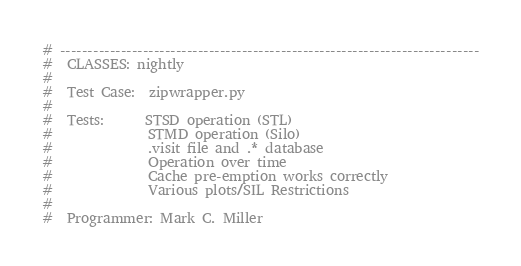Convert code to text. <code><loc_0><loc_0><loc_500><loc_500><_Python_># ----------------------------------------------------------------------------
#  CLASSES: nightly
#
#  Test Case:  zipwrapper.py 
#
#  Tests:      STSD operation (STL) 
#              STMD operation (Silo)
#              .visit file and .* database
#              Operation over time
#              Cache pre-emption works correctly 
#              Various plots/SIL Restrictions
#
#  Programmer: Mark C. Miller </code> 